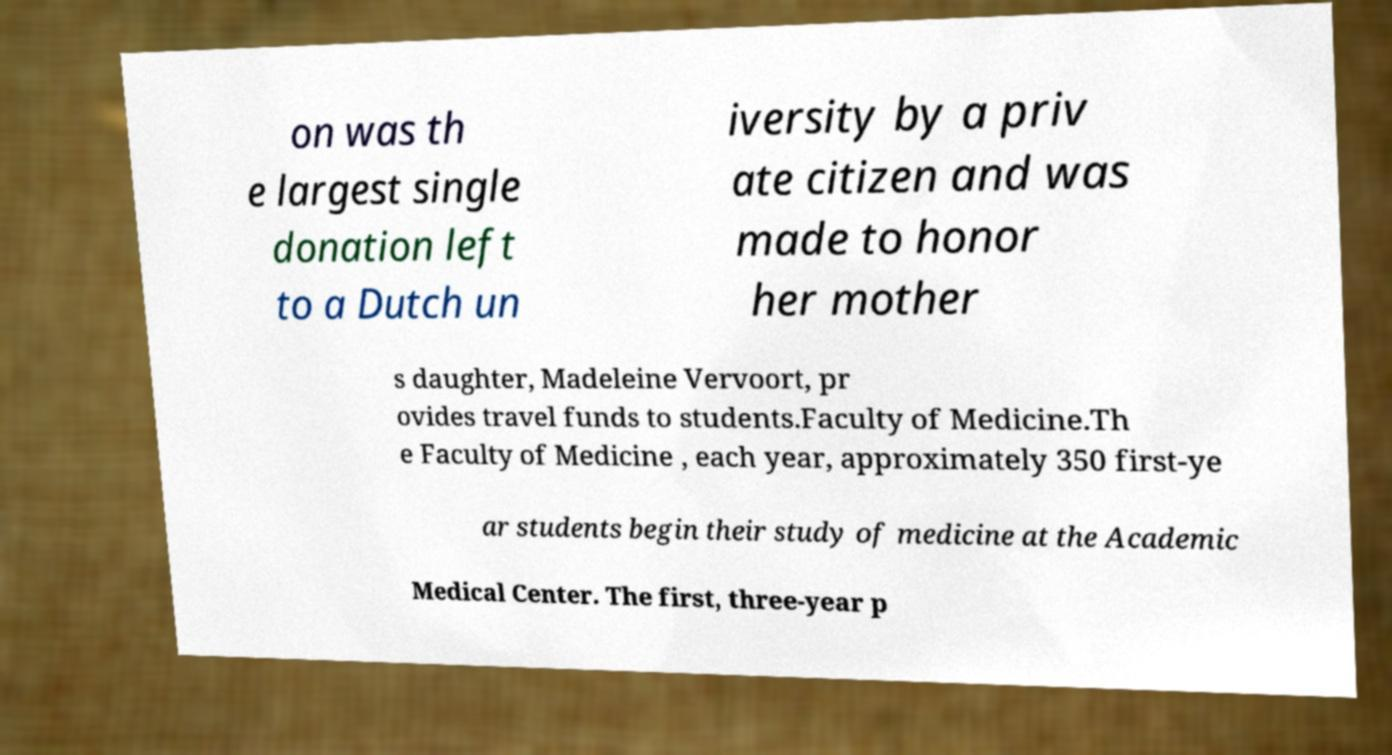Could you assist in decoding the text presented in this image and type it out clearly? on was th e largest single donation left to a Dutch un iversity by a priv ate citizen and was made to honor her mother s daughter, Madeleine Vervoort, pr ovides travel funds to students.Faculty of Medicine.Th e Faculty of Medicine , each year, approximately 350 first-ye ar students begin their study of medicine at the Academic Medical Center. The first, three-year p 